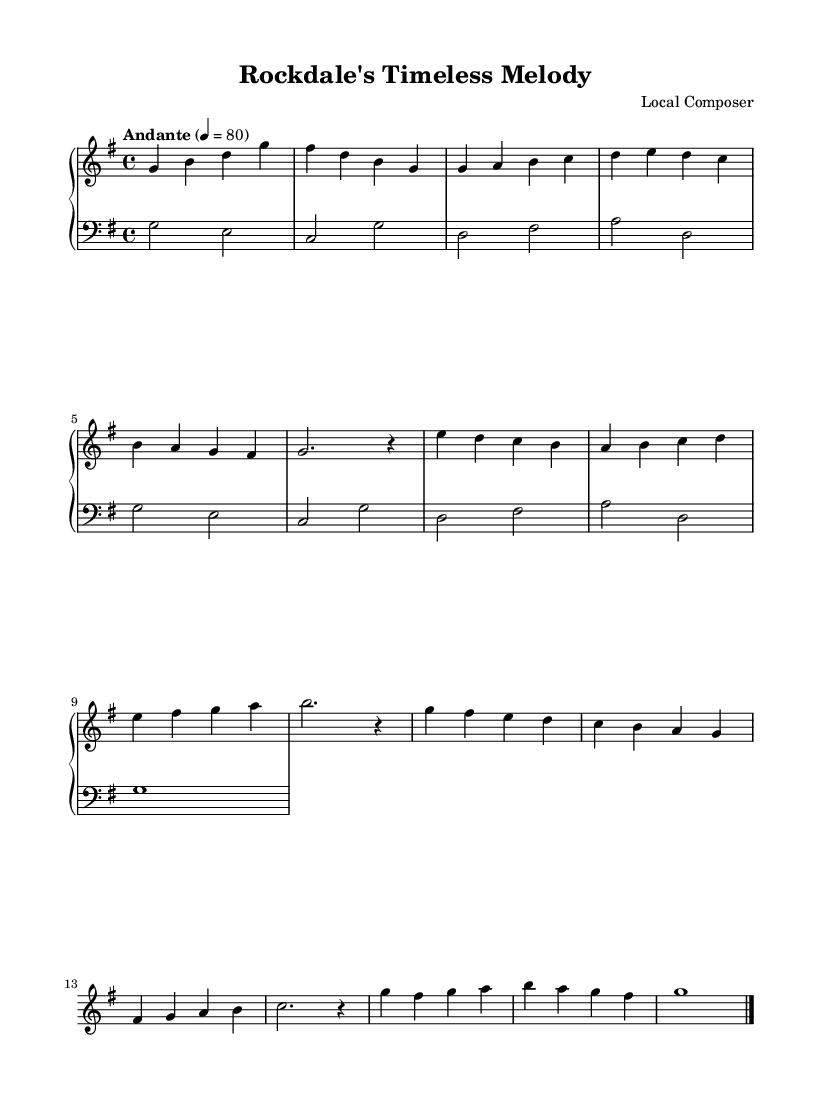What is the key signature of this music? The key signature is G major, which has one sharp (F#). This is indicated by the presence of the sharp sign placed on the F line in the staff.
Answer: G major What is the time signature of this music? The time signature is 4/4, which is shown at the beginning of the score. This means there are four beats in each measure, and the quarter note receives one beat.
Answer: 4/4 What is the tempo marking for this piece? The tempo marking is "Andante," which typically indicates a moderate walking pace. In this sheet music, the metronome marking of 4 equals 80 further clarifies the intended speed.
Answer: Andante How many musical themes are present in this piece? There are three distinct themes present in the piece: Theme A, Theme B, and a variation of Theme A. This can be seen as the score is structured into sections labeled accordingly.
Answer: Three What is the structure of the piece? The structure includes an introduction, two themes (A and B), a variation of Theme A, and a coda, as indicated in the phrasing of the music. Each section is clearly defined, allowing for a classical compositional form.
Answer: Introduction, Theme A, Theme B, Theme A variation, Coda What is the instrumentation indicated in this music? The instrumentation is for piano, as indicated by the "PianoStaff" at the beginning of the score, which includes both right hand and left hand staves organized for a piano performance.
Answer: Piano 